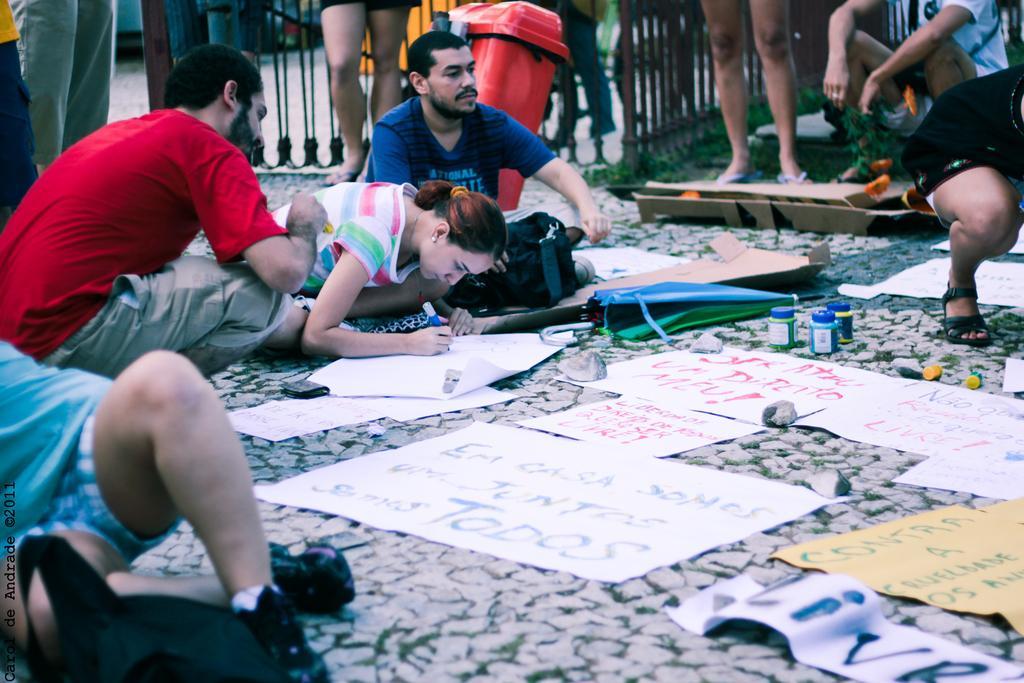In one or two sentences, can you explain what this image depicts? In this picture there is a woman who is wearing t-shirt and holding a pen. She is writing something on the people there is a man who is wearing blue t-shirt and holding a bag. On the left there is a man who is wearing t-shirt, shorts and he is sitting on the floor. At the bottom we can see papers, posters, umbrella and bag. In the background we can see the peoples were standing near to the fencing, beside them we can see the grass. 